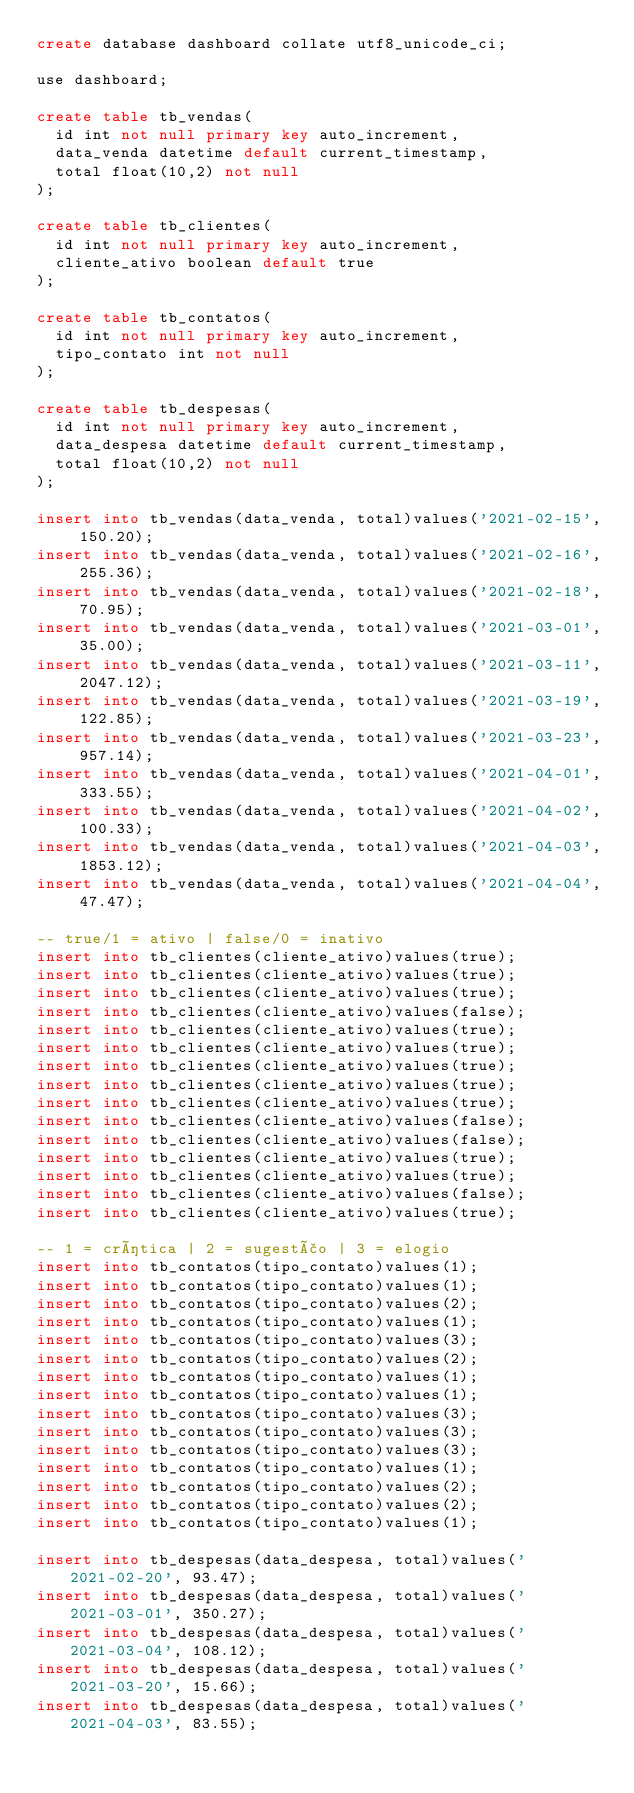<code> <loc_0><loc_0><loc_500><loc_500><_SQL_>create database dashboard collate utf8_unicode_ci;

use dashboard;

create table tb_vendas(
	id int not null primary key auto_increment,
	data_venda datetime default current_timestamp,
	total float(10,2) not null
);

create table tb_clientes(
	id int not null primary key auto_increment,
	cliente_ativo boolean default true
);

create table tb_contatos(
	id int not null primary key auto_increment,
	tipo_contato int not null
);

create table tb_despesas(
	id int not null primary key auto_increment,
	data_despesa datetime default current_timestamp,
	total float(10,2) not null
);

insert into tb_vendas(data_venda, total)values('2021-02-15', 150.20);
insert into tb_vendas(data_venda, total)values('2021-02-16', 255.36);
insert into tb_vendas(data_venda, total)values('2021-02-18', 70.95);
insert into tb_vendas(data_venda, total)values('2021-03-01', 35.00);
insert into tb_vendas(data_venda, total)values('2021-03-11', 2047.12);
insert into tb_vendas(data_venda, total)values('2021-03-19', 122.85);
insert into tb_vendas(data_venda, total)values('2021-03-23', 957.14);
insert into tb_vendas(data_venda, total)values('2021-04-01', 333.55);
insert into tb_vendas(data_venda, total)values('2021-04-02', 100.33);
insert into tb_vendas(data_venda, total)values('2021-04-03', 1853.12);
insert into tb_vendas(data_venda, total)values('2021-04-04', 47.47);

-- true/1 = ativo | false/0 = inativo
insert into tb_clientes(cliente_ativo)values(true);
insert into tb_clientes(cliente_ativo)values(true);
insert into tb_clientes(cliente_ativo)values(true);
insert into tb_clientes(cliente_ativo)values(false);
insert into tb_clientes(cliente_ativo)values(true);
insert into tb_clientes(cliente_ativo)values(true);
insert into tb_clientes(cliente_ativo)values(true);
insert into tb_clientes(cliente_ativo)values(true);
insert into tb_clientes(cliente_ativo)values(true);
insert into tb_clientes(cliente_ativo)values(false);
insert into tb_clientes(cliente_ativo)values(false);
insert into tb_clientes(cliente_ativo)values(true);
insert into tb_clientes(cliente_ativo)values(true);
insert into tb_clientes(cliente_ativo)values(false);
insert into tb_clientes(cliente_ativo)values(true);

-- 1 = crítica | 2 = sugestão | 3 = elogio
insert into tb_contatos(tipo_contato)values(1);
insert into tb_contatos(tipo_contato)values(1);
insert into tb_contatos(tipo_contato)values(2);
insert into tb_contatos(tipo_contato)values(1);
insert into tb_contatos(tipo_contato)values(3);
insert into tb_contatos(tipo_contato)values(2);
insert into tb_contatos(tipo_contato)values(1);
insert into tb_contatos(tipo_contato)values(1);
insert into tb_contatos(tipo_contato)values(3);
insert into tb_contatos(tipo_contato)values(3);
insert into tb_contatos(tipo_contato)values(3);
insert into tb_contatos(tipo_contato)values(1);
insert into tb_contatos(tipo_contato)values(2);
insert into tb_contatos(tipo_contato)values(2);
insert into tb_contatos(tipo_contato)values(1);

insert into tb_despesas(data_despesa, total)values('2021-02-20', 93.47);
insert into tb_despesas(data_despesa, total)values('2021-03-01', 350.27);
insert into tb_despesas(data_despesa, total)values('2021-03-04', 108.12);
insert into tb_despesas(data_despesa, total)values('2021-03-20', 15.66);
insert into tb_despesas(data_despesa, total)values('2021-04-03', 83.55);</code> 